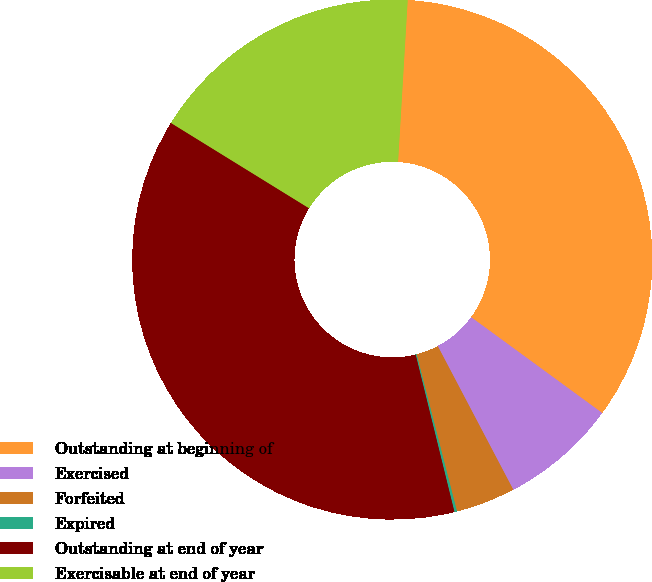<chart> <loc_0><loc_0><loc_500><loc_500><pie_chart><fcel>Outstanding at beginning of<fcel>Exercised<fcel>Forfeited<fcel>Expired<fcel>Outstanding at end of year<fcel>Exercisable at end of year<nl><fcel>34.1%<fcel>7.25%<fcel>3.7%<fcel>0.16%<fcel>37.65%<fcel>17.14%<nl></chart> 